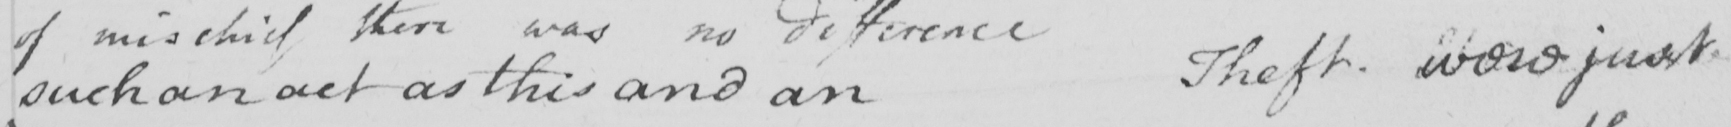What is written in this line of handwriting? such an act as this and an Theft . would just 